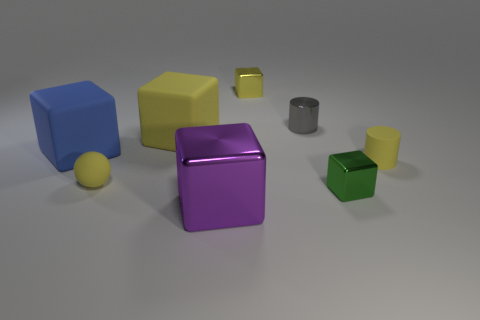There is a yellow cube in front of the shiny cube behind the tiny matte thing to the left of the large purple metal object; what size is it? The object in question appears to be a small yellow cube. Its size is much smaller than the large purple metallic cube when compared within the scene. 